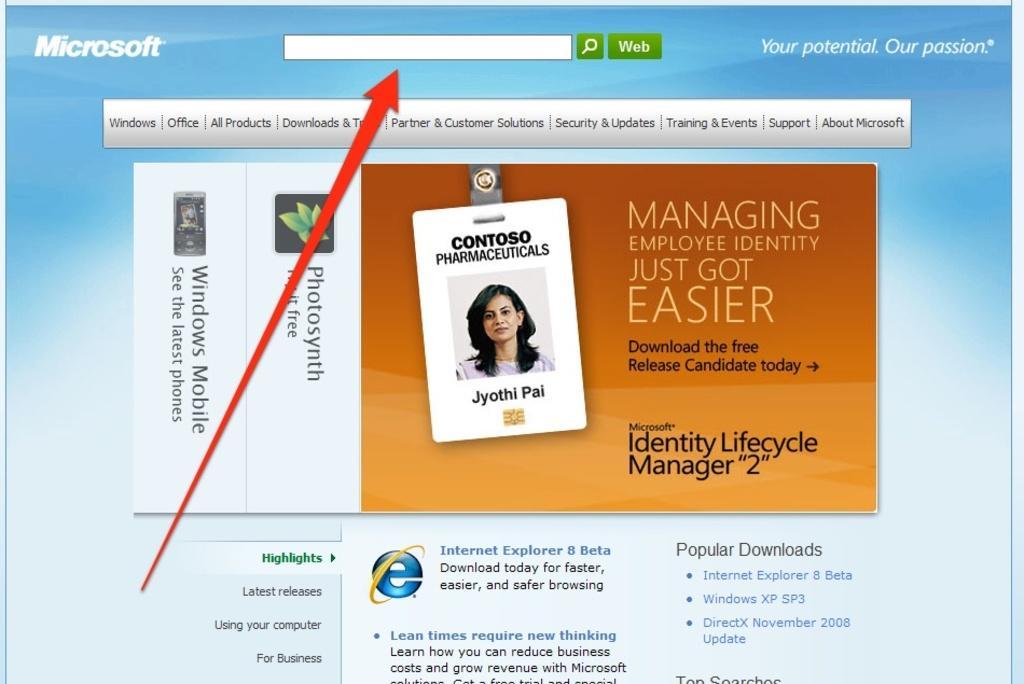Please provide a concise description of this image. In this image we can see a page of a website with some text, images, a photo of a person and logo. 